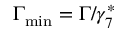<formula> <loc_0><loc_0><loc_500><loc_500>\Gamma _ { \min } = \Gamma / \gamma _ { 7 } ^ { \ast }</formula> 